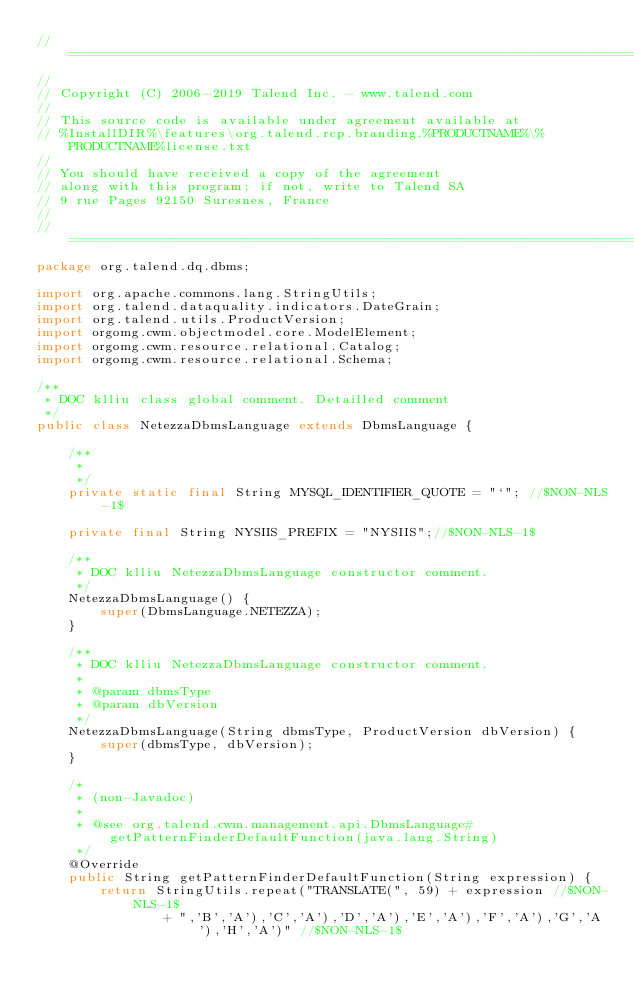Convert code to text. <code><loc_0><loc_0><loc_500><loc_500><_Java_>// ============================================================================
//
// Copyright (C) 2006-2019 Talend Inc. - www.talend.com
//
// This source code is available under agreement available at
// %InstallDIR%\features\org.talend.rcp.branding.%PRODUCTNAME%\%PRODUCTNAME%license.txt
//
// You should have received a copy of the agreement
// along with this program; if not, write to Talend SA
// 9 rue Pages 92150 Suresnes, France
//
// ============================================================================
package org.talend.dq.dbms;

import org.apache.commons.lang.StringUtils;
import org.talend.dataquality.indicators.DateGrain;
import org.talend.utils.ProductVersion;
import orgomg.cwm.objectmodel.core.ModelElement;
import orgomg.cwm.resource.relational.Catalog;
import orgomg.cwm.resource.relational.Schema;

/**
 * DOC klliu class global comment. Detailled comment
 */
public class NetezzaDbmsLanguage extends DbmsLanguage {

    /**
     *
     */
    private static final String MYSQL_IDENTIFIER_QUOTE = "`"; //$NON-NLS-1$

    private final String NYSIIS_PREFIX = "NYSIIS";//$NON-NLS-1$

    /**
     * DOC klliu NetezzaDbmsLanguage constructor comment.
     */
    NetezzaDbmsLanguage() {
        super(DbmsLanguage.NETEZZA);
    }

    /**
     * DOC klliu NetezzaDbmsLanguage constructor comment.
     *
     * @param dbmsType
     * @param dbVersion
     */
    NetezzaDbmsLanguage(String dbmsType, ProductVersion dbVersion) {
        super(dbmsType, dbVersion);
    }

    /*
     * (non-Javadoc)
     *
     * @see org.talend.cwm.management.api.DbmsLanguage#getPatternFinderDefaultFunction(java.lang.String)
     */
    @Override
    public String getPatternFinderDefaultFunction(String expression) {
        return StringUtils.repeat("TRANSLATE(", 59) + expression //$NON-NLS-1$
                + ",'B','A'),'C','A'),'D','A'),'E','A'),'F','A'),'G','A'),'H','A')" //$NON-NLS-1$</code> 